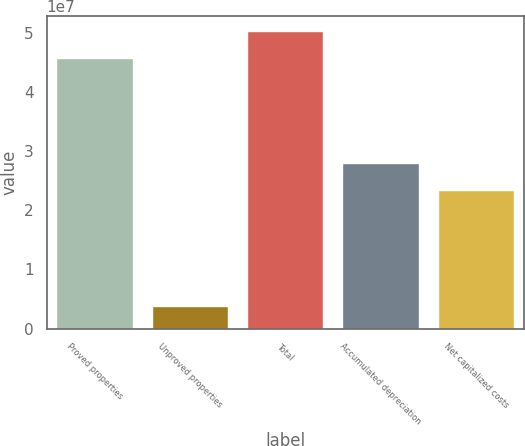<chart> <loc_0><loc_0><loc_500><loc_500><bar_chart><fcel>Proved properties<fcel>Unproved properties<fcel>Total<fcel>Accumulated depreciation<fcel>Net capitalized costs<nl><fcel>4.5752e+07<fcel>3.84013e+06<fcel>5.03272e+07<fcel>2.79202e+07<fcel>2.3345e+07<nl></chart> 